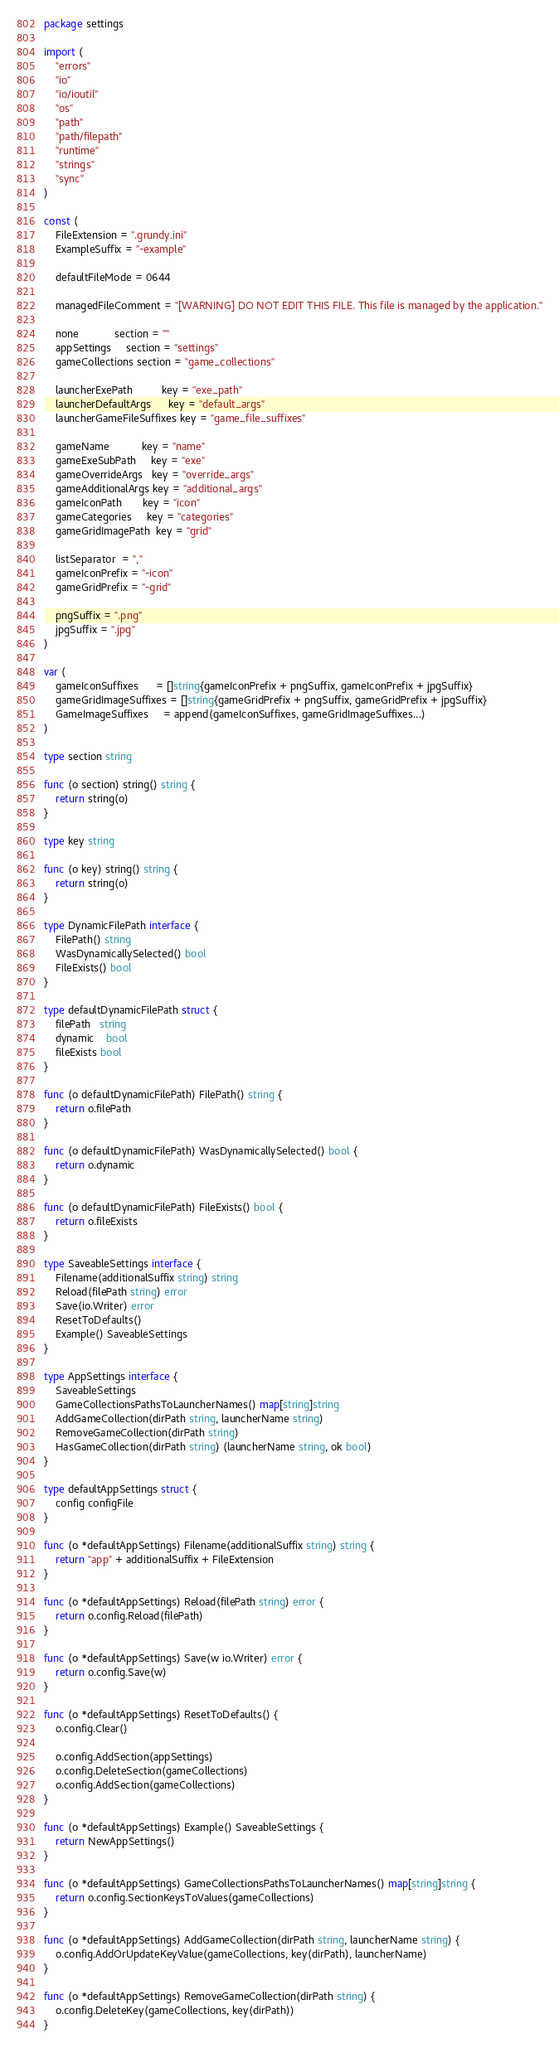Convert code to text. <code><loc_0><loc_0><loc_500><loc_500><_Go_>package settings

import (
	"errors"
	"io"
	"io/ioutil"
	"os"
	"path"
	"path/filepath"
	"runtime"
	"strings"
	"sync"
)

const (
	FileExtension = ".grundy.ini"
	ExampleSuffix = "-example"

	defaultFileMode = 0644

	managedFileComment = "[WARNING] DO NOT EDIT THIS FILE. This file is managed by the application."

	none            section = ""
	appSettings     section = "settings"
	gameCollections section = "game_collections"

	launcherExePath          key = "exe_path"
	launcherDefaultArgs      key = "default_args"
	launcherGameFileSuffixes key = "game_file_suffixes"

	gameName           key = "name"
	gameExeSubPath     key = "exe"
	gameOverrideArgs   key = "override_args"
	gameAdditionalArgs key = "additional_args"
	gameIconPath       key = "icon"
	gameCategories     key = "categories"
	gameGridImagePath  key = "grid"

	listSeparator  = ","
	gameIconPrefix = "-icon"
	gameGridPrefix = "-grid"

	pngSuffix = ".png"
	jpgSuffix = ".jpg"
)

var (
	gameIconSuffixes      = []string{gameIconPrefix + pngSuffix, gameIconPrefix + jpgSuffix}
	gameGridImageSuffixes = []string{gameGridPrefix + pngSuffix, gameGridPrefix + jpgSuffix}
	GameImageSuffixes     = append(gameIconSuffixes, gameGridImageSuffixes...)
)

type section string

func (o section) string() string {
	return string(o)
}

type key string

func (o key) string() string {
	return string(o)
}

type DynamicFilePath interface {
	FilePath() string
	WasDynamicallySelected() bool
	FileExists() bool
}

type defaultDynamicFilePath struct {
	filePath   string
	dynamic    bool
	fileExists bool
}

func (o defaultDynamicFilePath) FilePath() string {
	return o.filePath
}

func (o defaultDynamicFilePath) WasDynamicallySelected() bool {
	return o.dynamic
}

func (o defaultDynamicFilePath) FileExists() bool {
	return o.fileExists
}

type SaveableSettings interface {
	Filename(additionalSuffix string) string
	Reload(filePath string) error
	Save(io.Writer) error
	ResetToDefaults()
	Example() SaveableSettings
}

type AppSettings interface {
	SaveableSettings
	GameCollectionsPathsToLauncherNames() map[string]string
	AddGameCollection(dirPath string, launcherName string)
	RemoveGameCollection(dirPath string)
	HasGameCollection(dirPath string) (launcherName string, ok bool)
}

type defaultAppSettings struct {
	config configFile
}

func (o *defaultAppSettings) Filename(additionalSuffix string) string {
	return "app" + additionalSuffix + FileExtension
}

func (o *defaultAppSettings) Reload(filePath string) error {
	return o.config.Reload(filePath)
}

func (o *defaultAppSettings) Save(w io.Writer) error {
	return o.config.Save(w)
}

func (o *defaultAppSettings) ResetToDefaults() {
	o.config.Clear()

	o.config.AddSection(appSettings)
	o.config.DeleteSection(gameCollections)
	o.config.AddSection(gameCollections)
}

func (o *defaultAppSettings) Example() SaveableSettings {
	return NewAppSettings()
}

func (o *defaultAppSettings) GameCollectionsPathsToLauncherNames() map[string]string {
	return o.config.SectionKeysToValues(gameCollections)
}

func (o *defaultAppSettings) AddGameCollection(dirPath string, launcherName string) {
	o.config.AddOrUpdateKeyValue(gameCollections, key(dirPath), launcherName)
}

func (o *defaultAppSettings) RemoveGameCollection(dirPath string) {
	o.config.DeleteKey(gameCollections, key(dirPath))
}
</code> 